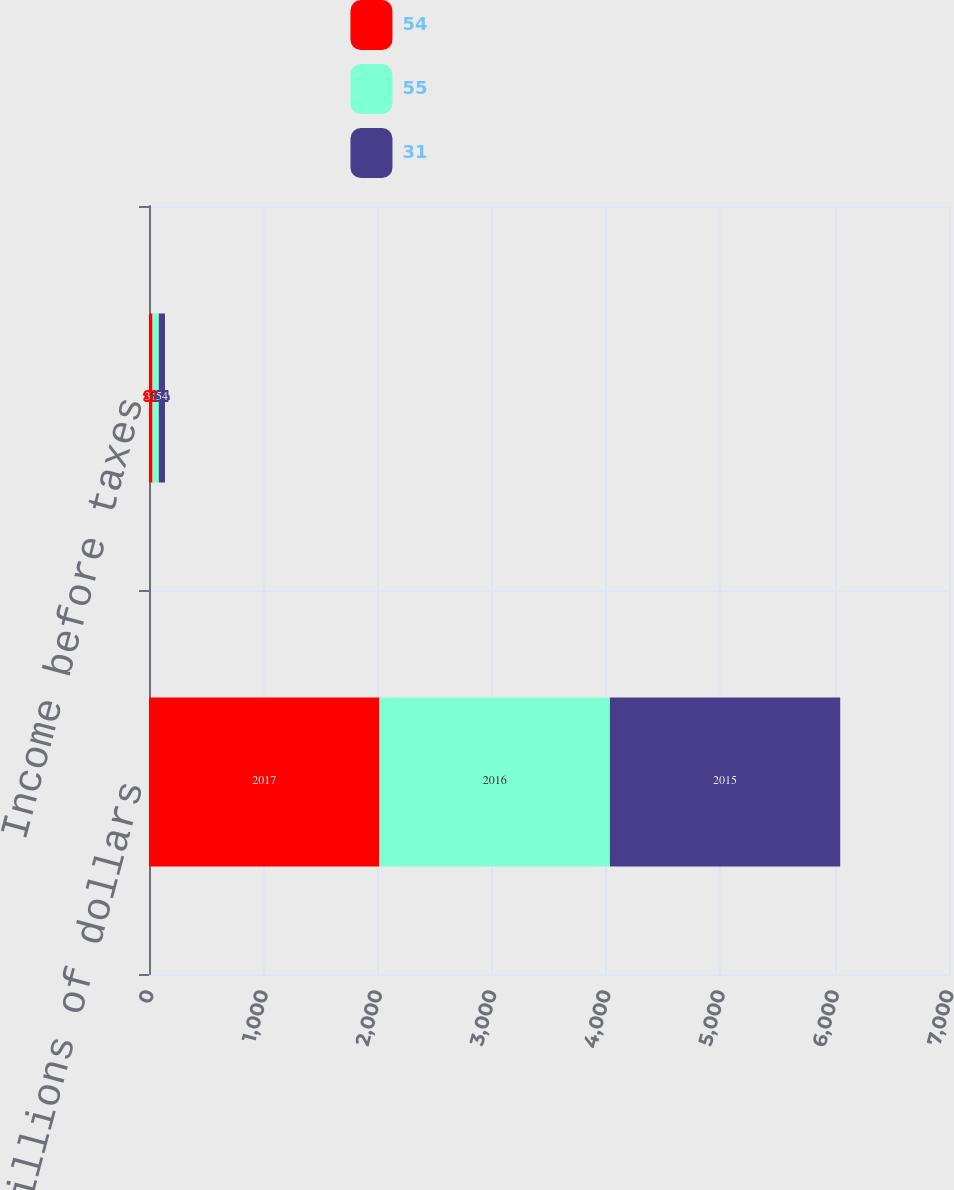Convert chart. <chart><loc_0><loc_0><loc_500><loc_500><stacked_bar_chart><ecel><fcel>In millions of dollars<fcel>Income before taxes<nl><fcel>54<fcel>2017<fcel>31<nl><fcel>55<fcel>2016<fcel>55<nl><fcel>31<fcel>2015<fcel>54<nl></chart> 